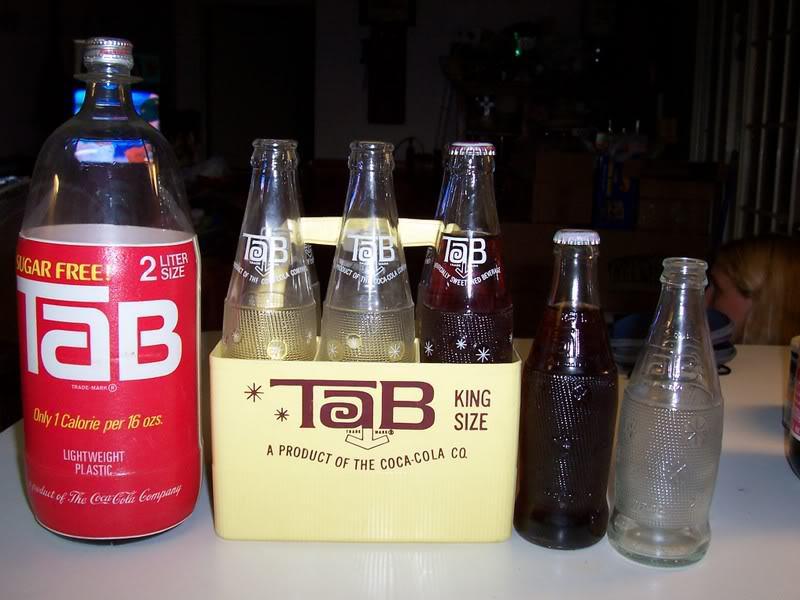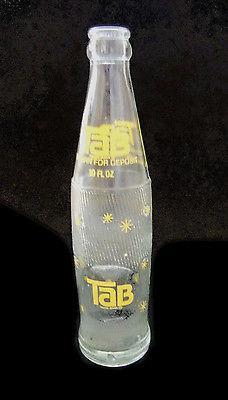The first image is the image on the left, the second image is the image on the right. Given the left and right images, does the statement "The right image contains one glass bottle with a dark colored liquid inside." hold true? Answer yes or no. No. 